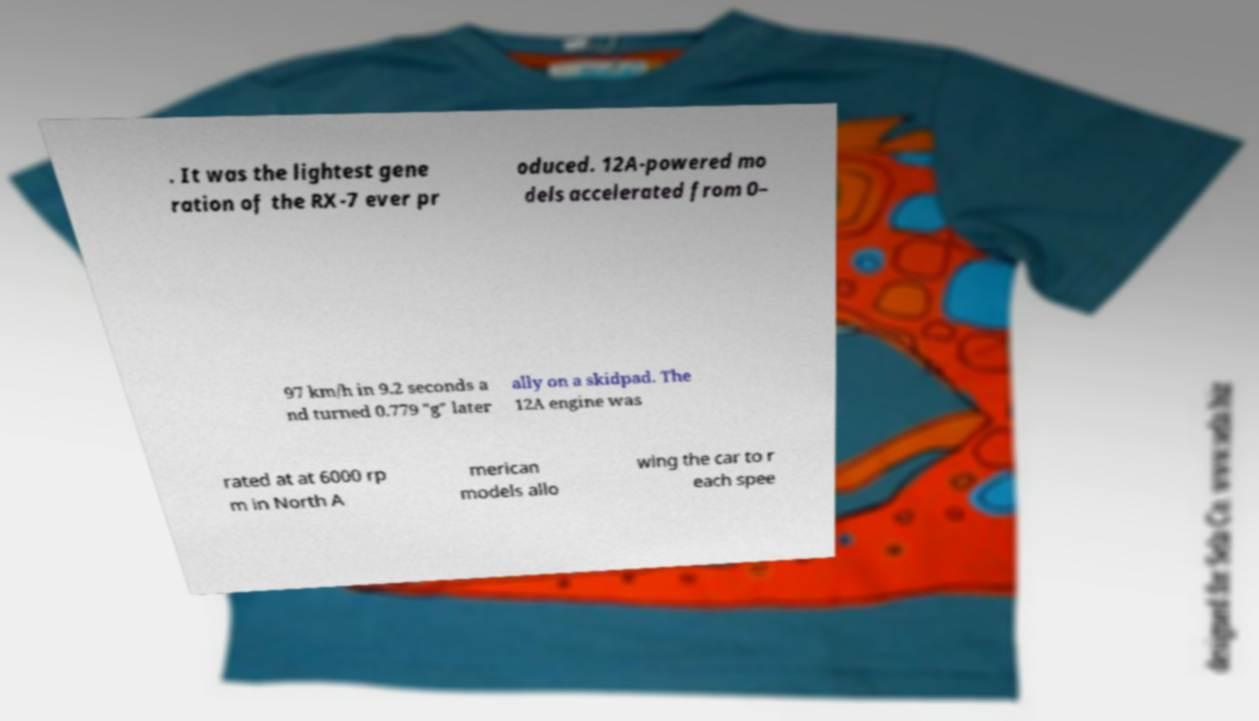I need the written content from this picture converted into text. Can you do that? . It was the lightest gene ration of the RX-7 ever pr oduced. 12A-powered mo dels accelerated from 0– 97 km/h in 9.2 seconds a nd turned 0.779 "g" later ally on a skidpad. The 12A engine was rated at at 6000 rp m in North A merican models allo wing the car to r each spee 